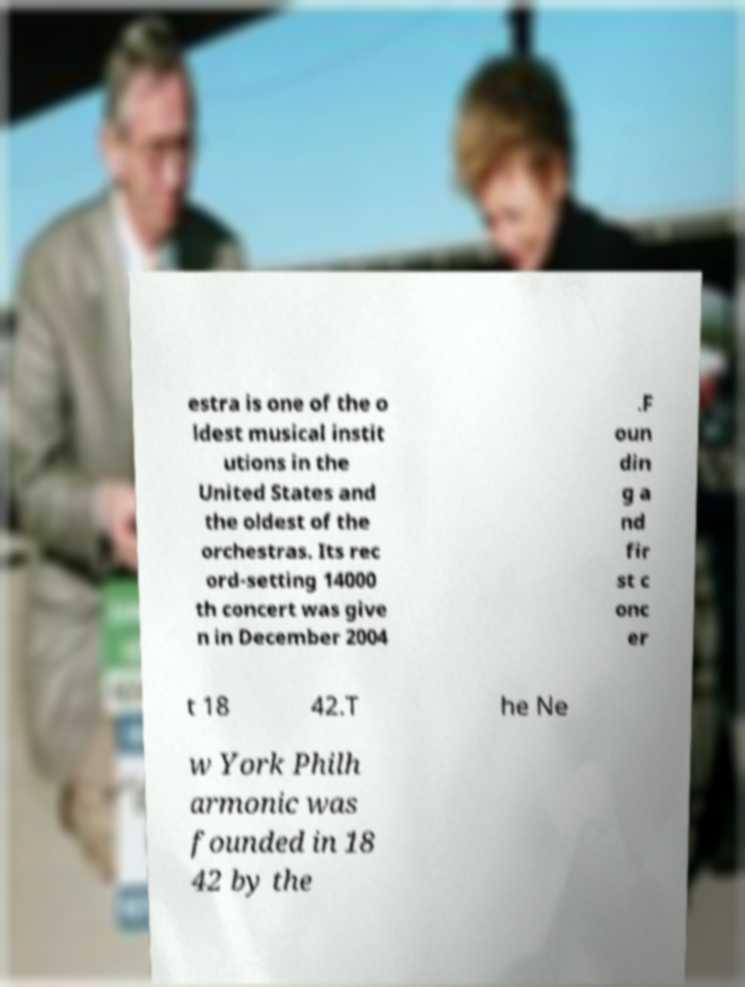There's text embedded in this image that I need extracted. Can you transcribe it verbatim? estra is one of the o ldest musical instit utions in the United States and the oldest of the orchestras. Its rec ord-setting 14000 th concert was give n in December 2004 .F oun din g a nd fir st c onc er t 18 42.T he Ne w York Philh armonic was founded in 18 42 by the 